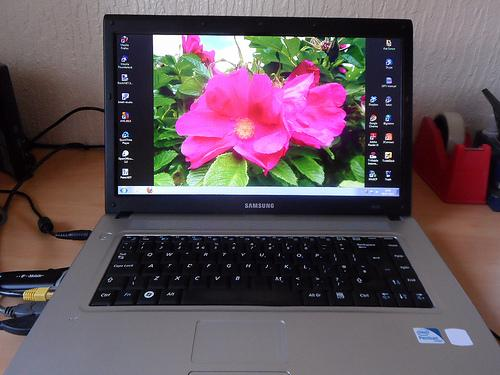Mention the brand name visible on the laptop, based on the information in the captions. Samsung logo is visible on the laptop screen. Can you tell me what is behind the laptop and describe its texture? A textured white wall made of stucco is behind the laptop. Identify the primary item on the table in the image and describe its color. A grey laptop is the primary item on the table. Describe the appearance of the power cable in the image. Black power cable Create a detailed caption for the image including the main objects and their characteristics. A grey open laptop on a wooden table with a black keyboard and white lettering, a red scotch tape dispenser, two pink flowers, and a textured white stucco wall behind it. What is the purpose of the rectangular area with buttons below the keyboard on the laptop? Mouse touchpad Are the flowers on top of the keyboard? No, it's not mentioned in the image. Are the desktop icons in the center of the screen? The given coordinates place the desktop icons on the corner of the screen (X:383, Y:40), not the center. The instruction falsely suggests the location of the icons. Identify the action happening in the image. No action is happening in the image, just objects displayed. What type of wall is in the background? Textured white stucco wall Is the scotch tape dispenser green? The scotch tape dispenser is described as red in the image, not green. Using a color that is not mentioned in the given information is misleading. What event is taking place in the image? There is no particular event, it is an image of various objects. What brand is the laptop in the image? Samsung Describe the position of the flowers in relation to the laptop. The flowers are to the right and above the laptop. Describe the appearance of the computer keyboard in the image. Black keyboard with white lettering Is the table on the wooden wall? The table is not on the wall. They are separate objects in the image with different coordinates, and tables are usually placed on the floor, not on a wall. What can be seen on the computer screen? Icons Is the samsung logo on the black modem? The samsung logo is mentioned to be on the laptop screen and not on the modem. Associating a brand's logo with the wrong object is misleading. Select the correct description for the electronics in the image: a) cellphone and printer, b) laptop and modem, c) TV and speakers. b) laptop and modem Describe the color and texture of the wall in the image. White and textured What can be seen on the monitor of the laptop? Desktop page with icons and Samsung logo Describe the material and appearance of the table in the image. Wooden computer desk Can you identify any item in the image that can be used for adhering things together? Red scotch tape dispenser What is the color of the scotch tape dispenser? Red Choose the correct description of the flowers in the image: a) single red flower, b) two pink flowers, c) five blue flowers. b) two pink flowers 